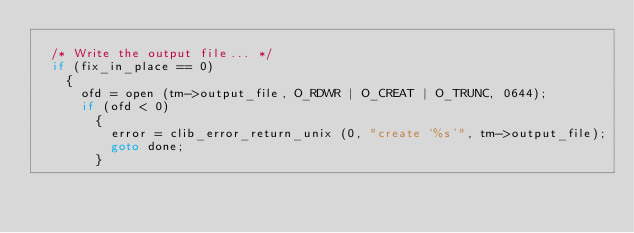Convert code to text. <code><loc_0><loc_0><loc_500><loc_500><_C_>
  /* Write the output file... */
  if (fix_in_place == 0)
    {
      ofd = open (tm->output_file, O_RDWR | O_CREAT | O_TRUNC, 0644);
      if (ofd < 0)
        {
          error = clib_error_return_unix (0, "create `%s'", tm->output_file);
          goto done;
        }
</code> 